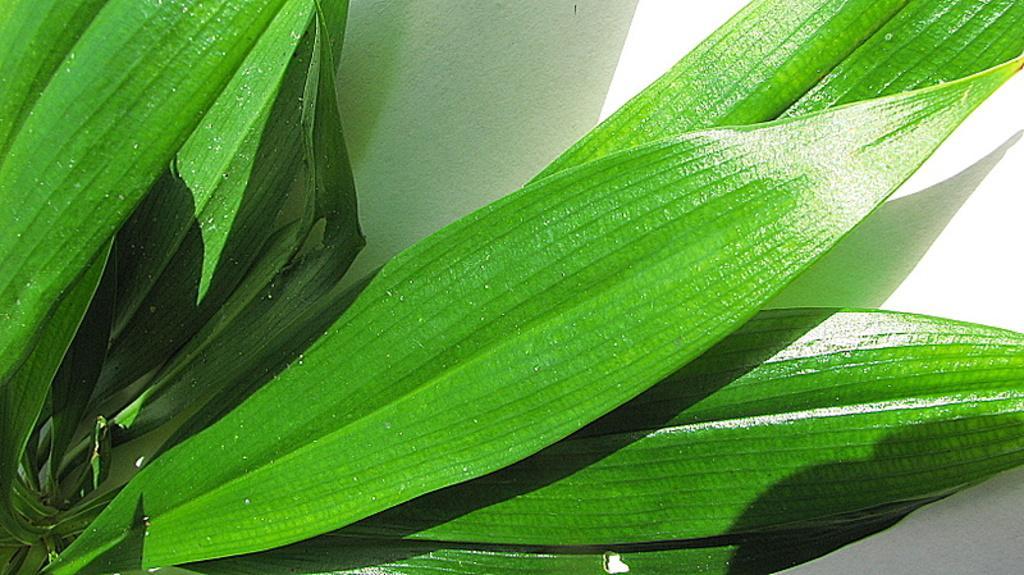Describe this image in one or two sentences. In this image I can see a plant which is green in color and in the background I can see a white colored surface. 